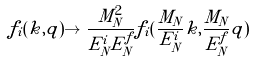Convert formula to latex. <formula><loc_0><loc_0><loc_500><loc_500>f _ { i } ( { k } , { q } ) \to \frac { M _ { N } ^ { 2 } } { E _ { N } ^ { i } E _ { N } ^ { f } } f _ { i } ( \frac { M _ { N } } { E ^ { i } _ { N } } { k } , \frac { M _ { N } } { E _ { N } ^ { f } } { q } )</formula> 